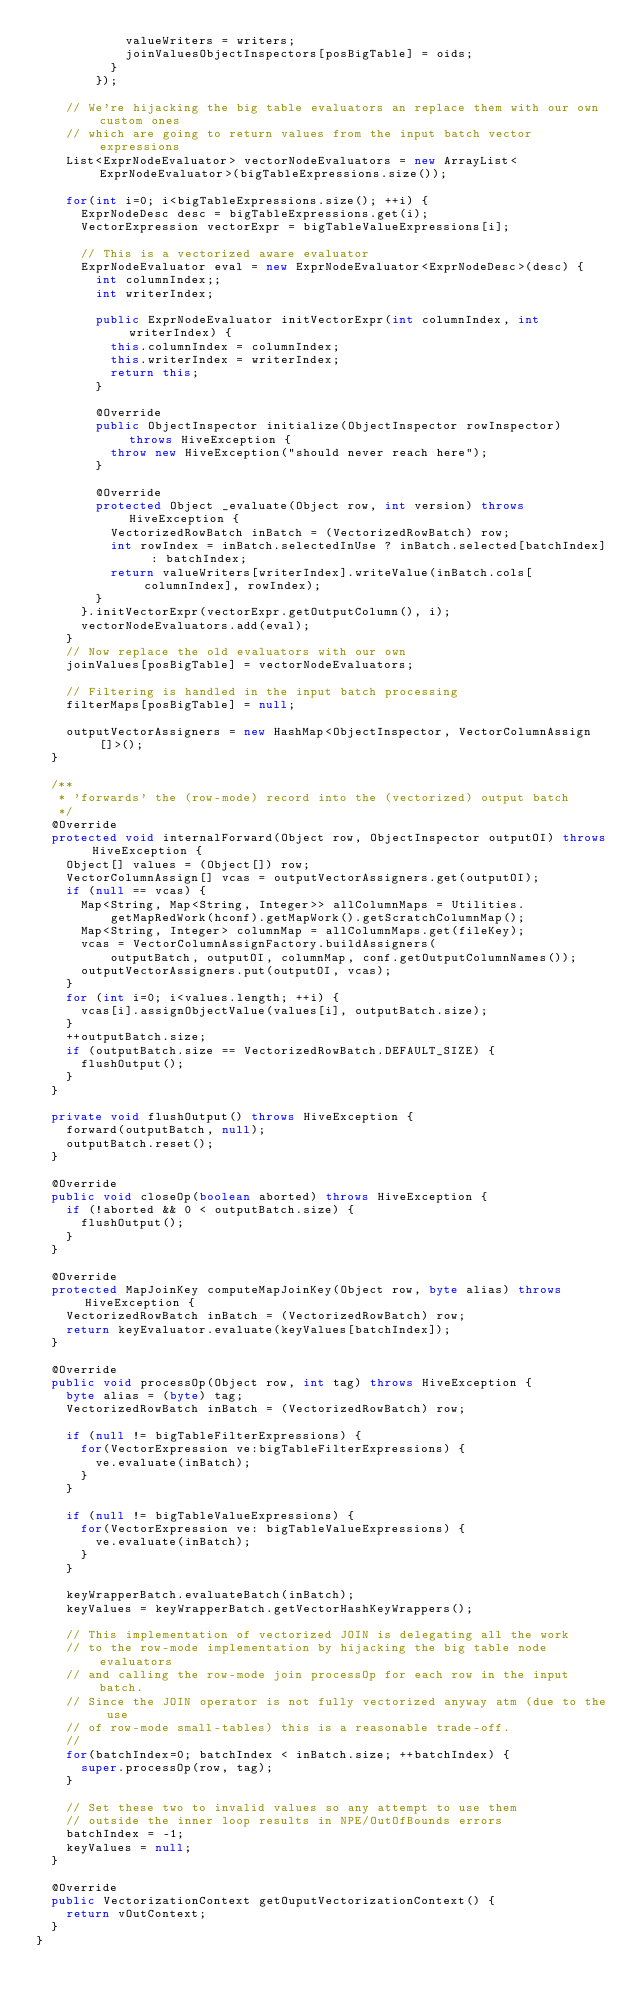Convert code to text. <code><loc_0><loc_0><loc_500><loc_500><_Java_>            valueWriters = writers;
            joinValuesObjectInspectors[posBigTable] = oids;
          }
        });

    // We're hijacking the big table evaluators an replace them with our own custom ones
    // which are going to return values from the input batch vector expressions
    List<ExprNodeEvaluator> vectorNodeEvaluators = new ArrayList<ExprNodeEvaluator>(bigTableExpressions.size());

    for(int i=0; i<bigTableExpressions.size(); ++i) {
      ExprNodeDesc desc = bigTableExpressions.get(i);
      VectorExpression vectorExpr = bigTableValueExpressions[i];

      // This is a vectorized aware evaluator
      ExprNodeEvaluator eval = new ExprNodeEvaluator<ExprNodeDesc>(desc) {
        int columnIndex;;
        int writerIndex;

        public ExprNodeEvaluator initVectorExpr(int columnIndex, int writerIndex) {
          this.columnIndex = columnIndex;
          this.writerIndex = writerIndex;
          return this;
        }

        @Override
        public ObjectInspector initialize(ObjectInspector rowInspector) throws HiveException {
          throw new HiveException("should never reach here");
        }

        @Override
        protected Object _evaluate(Object row, int version) throws HiveException {
          VectorizedRowBatch inBatch = (VectorizedRowBatch) row;
          int rowIndex = inBatch.selectedInUse ? inBatch.selected[batchIndex] : batchIndex;
          return valueWriters[writerIndex].writeValue(inBatch.cols[columnIndex], rowIndex);
        }
      }.initVectorExpr(vectorExpr.getOutputColumn(), i);
      vectorNodeEvaluators.add(eval);
    }
    // Now replace the old evaluators with our own
    joinValues[posBigTable] = vectorNodeEvaluators;

    // Filtering is handled in the input batch processing
    filterMaps[posBigTable] = null;

    outputVectorAssigners = new HashMap<ObjectInspector, VectorColumnAssign[]>();
  }

  /**
   * 'forwards' the (row-mode) record into the (vectorized) output batch
   */
  @Override
  protected void internalForward(Object row, ObjectInspector outputOI) throws HiveException {
    Object[] values = (Object[]) row;
    VectorColumnAssign[] vcas = outputVectorAssigners.get(outputOI);
    if (null == vcas) {
      Map<String, Map<String, Integer>> allColumnMaps = Utilities.
          getMapRedWork(hconf).getMapWork().getScratchColumnMap();
      Map<String, Integer> columnMap = allColumnMaps.get(fileKey);
      vcas = VectorColumnAssignFactory.buildAssigners(
          outputBatch, outputOI, columnMap, conf.getOutputColumnNames());
      outputVectorAssigners.put(outputOI, vcas);
    }
    for (int i=0; i<values.length; ++i) {
      vcas[i].assignObjectValue(values[i], outputBatch.size);
    }
    ++outputBatch.size;
    if (outputBatch.size == VectorizedRowBatch.DEFAULT_SIZE) {
      flushOutput();
    }
  }

  private void flushOutput() throws HiveException {
    forward(outputBatch, null);
    outputBatch.reset();
  }

  @Override
  public void closeOp(boolean aborted) throws HiveException {
    if (!aborted && 0 < outputBatch.size) {
      flushOutput();
    }
  }

  @Override
  protected MapJoinKey computeMapJoinKey(Object row, byte alias) throws HiveException {
    VectorizedRowBatch inBatch = (VectorizedRowBatch) row;
    return keyEvaluator.evaluate(keyValues[batchIndex]);
  }

  @Override
  public void processOp(Object row, int tag) throws HiveException {
    byte alias = (byte) tag;
    VectorizedRowBatch inBatch = (VectorizedRowBatch) row;

    if (null != bigTableFilterExpressions) {
      for(VectorExpression ve:bigTableFilterExpressions) {
        ve.evaluate(inBatch);
      }
    }

    if (null != bigTableValueExpressions) {
      for(VectorExpression ve: bigTableValueExpressions) {
        ve.evaluate(inBatch);
      }
    }

    keyWrapperBatch.evaluateBatch(inBatch);
    keyValues = keyWrapperBatch.getVectorHashKeyWrappers();

    // This implementation of vectorized JOIN is delegating all the work
    // to the row-mode implementation by hijacking the big table node evaluators
    // and calling the row-mode join processOp for each row in the input batch.
    // Since the JOIN operator is not fully vectorized anyway atm (due to the use
    // of row-mode small-tables) this is a reasonable trade-off.
    //
    for(batchIndex=0; batchIndex < inBatch.size; ++batchIndex) {
      super.processOp(row, tag);
    }

    // Set these two to invalid values so any attempt to use them
    // outside the inner loop results in NPE/OutOfBounds errors
    batchIndex = -1;
    keyValues = null;
  }

  @Override
  public VectorizationContext getOuputVectorizationContext() {
    return vOutContext;
  }
}
</code> 